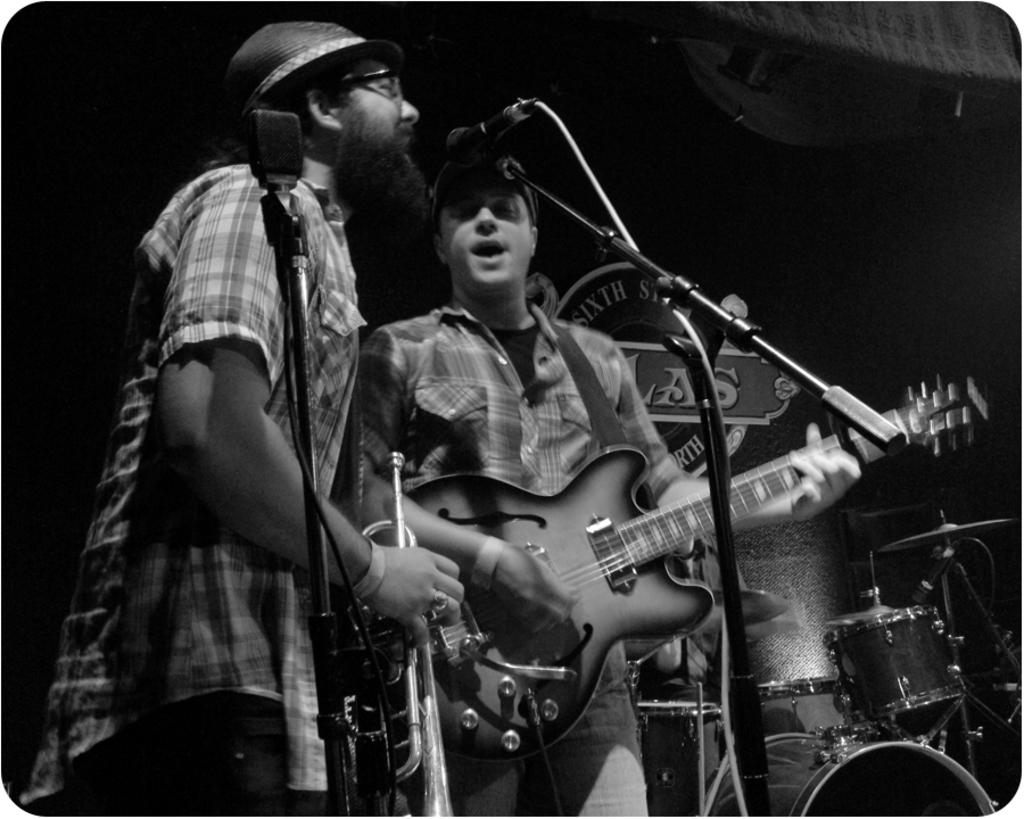How many people are in the image? There are two persons in the image. What are the two persons doing? The two persons are standing and singing a song. What is one of the persons holding? One of the persons is playing a guitar. What else can be seen in the image related to music? There are musical instruments visible in the background. What type of iron can be seen in the image? There is no iron present in the image. Can you describe the hall where the two persons are singing? The provided facts do not mention a hall or any specific location where the two persons are singing. 